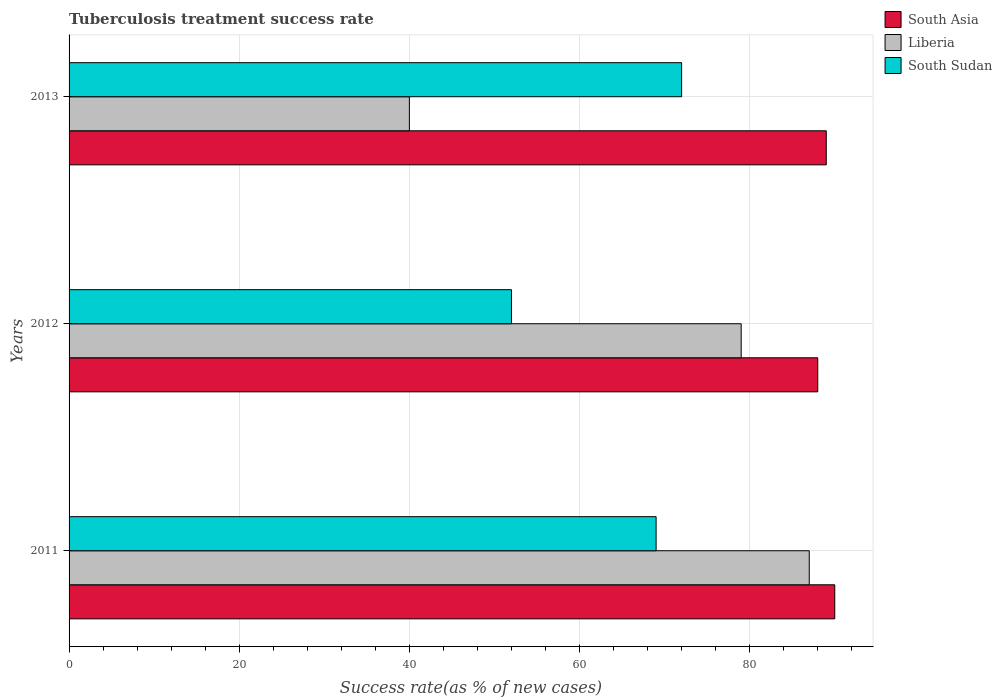How many different coloured bars are there?
Ensure brevity in your answer.  3. How many bars are there on the 2nd tick from the top?
Offer a very short reply. 3. What is the label of the 1st group of bars from the top?
Make the answer very short. 2013. What is the tuberculosis treatment success rate in South Asia in 2013?
Your response must be concise. 89. Across all years, what is the minimum tuberculosis treatment success rate in South Sudan?
Ensure brevity in your answer.  52. In which year was the tuberculosis treatment success rate in South Sudan maximum?
Your answer should be very brief. 2013. What is the total tuberculosis treatment success rate in Liberia in the graph?
Your response must be concise. 206. What is the difference between the tuberculosis treatment success rate in Liberia in 2011 and that in 2012?
Your response must be concise. 8. What is the average tuberculosis treatment success rate in South Asia per year?
Provide a short and direct response. 89. In how many years, is the tuberculosis treatment success rate in South Sudan greater than 16 %?
Give a very brief answer. 3. What is the ratio of the tuberculosis treatment success rate in South Sudan in 2011 to that in 2013?
Offer a terse response. 0.96. What is the difference between the highest and the second highest tuberculosis treatment success rate in South Asia?
Ensure brevity in your answer.  1. What is the difference between the highest and the lowest tuberculosis treatment success rate in Liberia?
Your response must be concise. 47. What does the 2nd bar from the top in 2013 represents?
Your answer should be very brief. Liberia. What does the 2nd bar from the bottom in 2013 represents?
Offer a very short reply. Liberia. Is it the case that in every year, the sum of the tuberculosis treatment success rate in South Asia and tuberculosis treatment success rate in Liberia is greater than the tuberculosis treatment success rate in South Sudan?
Your answer should be very brief. Yes. What is the difference between two consecutive major ticks on the X-axis?
Keep it short and to the point. 20. Are the values on the major ticks of X-axis written in scientific E-notation?
Give a very brief answer. No. What is the title of the graph?
Your answer should be compact. Tuberculosis treatment success rate. Does "Nepal" appear as one of the legend labels in the graph?
Offer a very short reply. No. What is the label or title of the X-axis?
Make the answer very short. Success rate(as % of new cases). What is the Success rate(as % of new cases) in Liberia in 2011?
Offer a terse response. 87. What is the Success rate(as % of new cases) of South Asia in 2012?
Provide a short and direct response. 88. What is the Success rate(as % of new cases) of Liberia in 2012?
Give a very brief answer. 79. What is the Success rate(as % of new cases) in South Sudan in 2012?
Your answer should be very brief. 52. What is the Success rate(as % of new cases) of South Asia in 2013?
Offer a terse response. 89. What is the Success rate(as % of new cases) in Liberia in 2013?
Offer a terse response. 40. Across all years, what is the maximum Success rate(as % of new cases) in South Asia?
Provide a short and direct response. 90. Across all years, what is the minimum Success rate(as % of new cases) of Liberia?
Ensure brevity in your answer.  40. Across all years, what is the minimum Success rate(as % of new cases) in South Sudan?
Provide a short and direct response. 52. What is the total Success rate(as % of new cases) in South Asia in the graph?
Offer a very short reply. 267. What is the total Success rate(as % of new cases) of Liberia in the graph?
Your answer should be very brief. 206. What is the total Success rate(as % of new cases) of South Sudan in the graph?
Your answer should be compact. 193. What is the difference between the Success rate(as % of new cases) in Liberia in 2011 and that in 2012?
Make the answer very short. 8. What is the difference between the Success rate(as % of new cases) of Liberia in 2011 and that in 2013?
Provide a succinct answer. 47. What is the difference between the Success rate(as % of new cases) in South Asia in 2012 and that in 2013?
Offer a terse response. -1. What is the difference between the Success rate(as % of new cases) in Liberia in 2012 and that in 2013?
Provide a succinct answer. 39. What is the difference between the Success rate(as % of new cases) of South Sudan in 2012 and that in 2013?
Your response must be concise. -20. What is the difference between the Success rate(as % of new cases) of South Asia in 2011 and the Success rate(as % of new cases) of Liberia in 2012?
Provide a succinct answer. 11. What is the difference between the Success rate(as % of new cases) of Liberia in 2011 and the Success rate(as % of new cases) of South Sudan in 2012?
Offer a terse response. 35. What is the difference between the Success rate(as % of new cases) in South Asia in 2011 and the Success rate(as % of new cases) in Liberia in 2013?
Offer a terse response. 50. What is the difference between the Success rate(as % of new cases) of South Asia in 2011 and the Success rate(as % of new cases) of South Sudan in 2013?
Your response must be concise. 18. What is the difference between the Success rate(as % of new cases) in South Asia in 2012 and the Success rate(as % of new cases) in Liberia in 2013?
Your answer should be very brief. 48. What is the average Success rate(as % of new cases) of South Asia per year?
Offer a terse response. 89. What is the average Success rate(as % of new cases) in Liberia per year?
Your answer should be compact. 68.67. What is the average Success rate(as % of new cases) in South Sudan per year?
Provide a short and direct response. 64.33. In the year 2011, what is the difference between the Success rate(as % of new cases) in South Asia and Success rate(as % of new cases) in South Sudan?
Your answer should be compact. 21. In the year 2011, what is the difference between the Success rate(as % of new cases) in Liberia and Success rate(as % of new cases) in South Sudan?
Your answer should be very brief. 18. In the year 2012, what is the difference between the Success rate(as % of new cases) in South Asia and Success rate(as % of new cases) in Liberia?
Your answer should be very brief. 9. In the year 2012, what is the difference between the Success rate(as % of new cases) of Liberia and Success rate(as % of new cases) of South Sudan?
Offer a terse response. 27. In the year 2013, what is the difference between the Success rate(as % of new cases) of South Asia and Success rate(as % of new cases) of Liberia?
Provide a succinct answer. 49. In the year 2013, what is the difference between the Success rate(as % of new cases) in South Asia and Success rate(as % of new cases) in South Sudan?
Give a very brief answer. 17. In the year 2013, what is the difference between the Success rate(as % of new cases) in Liberia and Success rate(as % of new cases) in South Sudan?
Your answer should be very brief. -32. What is the ratio of the Success rate(as % of new cases) in South Asia in 2011 to that in 2012?
Your answer should be compact. 1.02. What is the ratio of the Success rate(as % of new cases) of Liberia in 2011 to that in 2012?
Provide a short and direct response. 1.1. What is the ratio of the Success rate(as % of new cases) of South Sudan in 2011 to that in 2012?
Your response must be concise. 1.33. What is the ratio of the Success rate(as % of new cases) in South Asia in 2011 to that in 2013?
Your response must be concise. 1.01. What is the ratio of the Success rate(as % of new cases) of Liberia in 2011 to that in 2013?
Provide a succinct answer. 2.17. What is the ratio of the Success rate(as % of new cases) in Liberia in 2012 to that in 2013?
Offer a very short reply. 1.98. What is the ratio of the Success rate(as % of new cases) of South Sudan in 2012 to that in 2013?
Provide a succinct answer. 0.72. What is the difference between the highest and the second highest Success rate(as % of new cases) in Liberia?
Offer a very short reply. 8. What is the difference between the highest and the second highest Success rate(as % of new cases) in South Sudan?
Offer a terse response. 3. What is the difference between the highest and the lowest Success rate(as % of new cases) in South Asia?
Your answer should be compact. 2. What is the difference between the highest and the lowest Success rate(as % of new cases) of Liberia?
Provide a short and direct response. 47. 